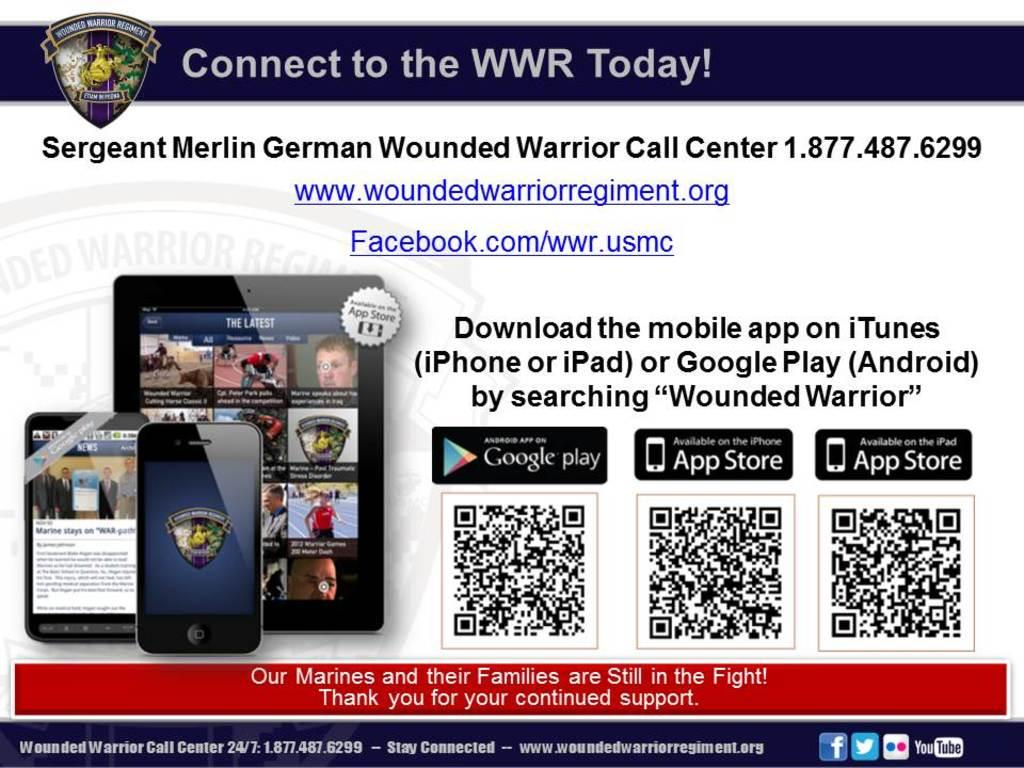<image>
Provide a brief description of the given image. An advertisement with a cell phone and tablet on it that says Sergeant Merlin German Wounded Warrior Call Center and the number. 